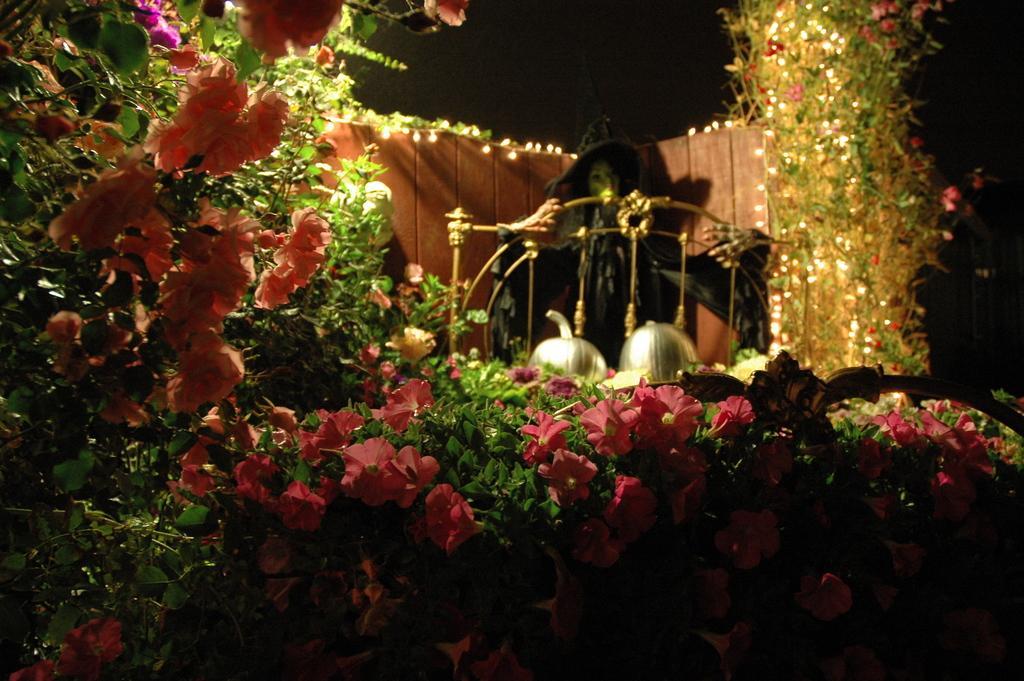How would you summarize this image in a sentence or two? In this image I can see few colorful flowers, plants, lights, black color toy and silver and gold color objects. Background is dark. 